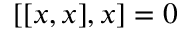<formula> <loc_0><loc_0><loc_500><loc_500>[ [ x , x ] , x ] = 0</formula> 